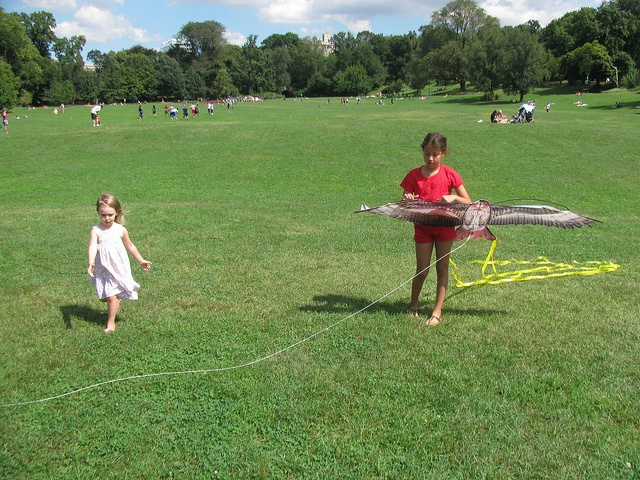Describe the objects in this image and their specific colors. I can see people in darkgray, maroon, gray, red, and brown tones, kite in darkgray, gray, and lightgray tones, people in darkgray, white, olive, lightpink, and gray tones, people in darkgray, olive, black, and gray tones, and people in darkgray, white, gray, olive, and lightpink tones in this image. 